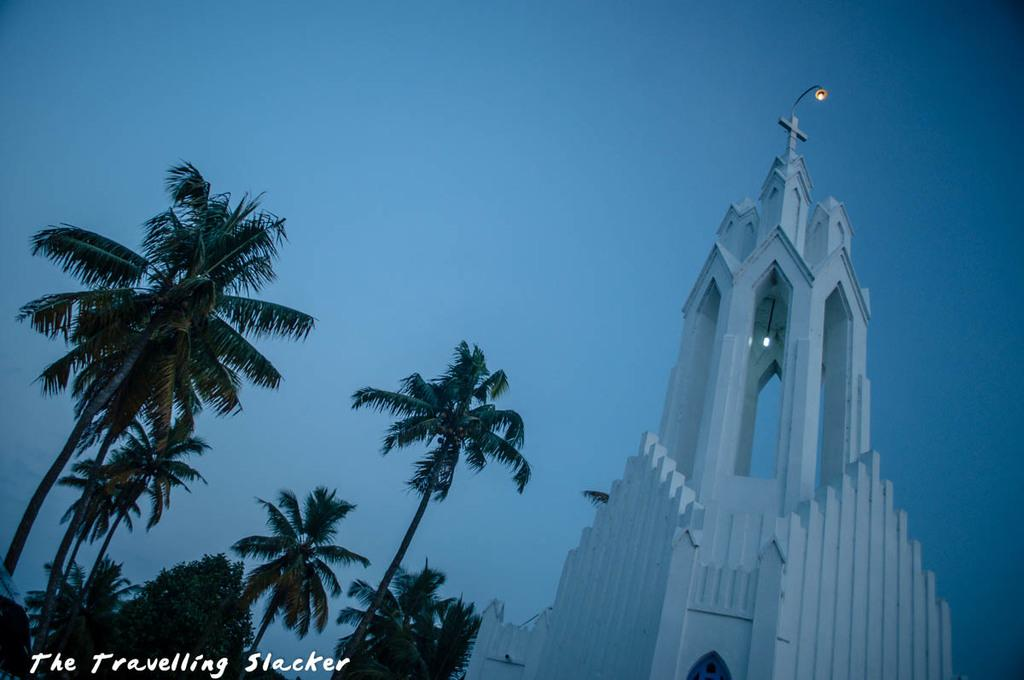What type of structure is present in the picture? There is a building in the picture. What other natural elements can be seen in the picture? There are trees in the picture. What is the color of the sky in the picture? The sky is blue in the picture. Are there any artificial light sources visible in the picture? Yes, there are lights visible in the picture. What is located at the bottom left corner of the picture? There is text at the bottom left corner of the picture. Can you describe the fog in the downtown area of the image? There is no fog or downtown area mentioned in the image. What type of lamp is hanging from the tree in the image? There is no lamp present in the image. 